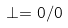Convert formula to latex. <formula><loc_0><loc_0><loc_500><loc_500>\perp = 0 / 0</formula> 